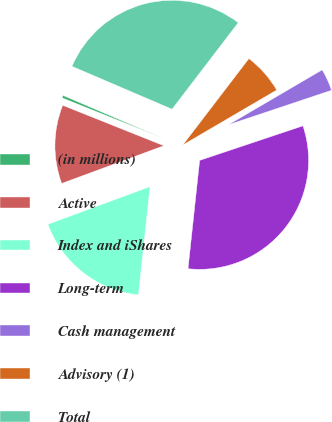Convert chart to OTSL. <chart><loc_0><loc_0><loc_500><loc_500><pie_chart><fcel>(in millions)<fcel>Active<fcel>Index and iShares<fcel>Long-term<fcel>Cash management<fcel>Advisory (1)<fcel>Total<nl><fcel>0.39%<fcel>11.68%<fcel>17.67%<fcel>31.84%<fcel>3.29%<fcel>6.18%<fcel>28.95%<nl></chart> 